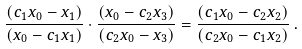Convert formula to latex. <formula><loc_0><loc_0><loc_500><loc_500>\frac { ( c _ { 1 } x _ { 0 } - x _ { 1 } ) } { ( x _ { 0 } - c _ { 1 } x _ { 1 } ) } \cdot \frac { ( x _ { 0 } - c _ { 2 } x _ { 3 } ) } { ( c _ { 2 } x _ { 0 } - x _ { 3 } ) } = \frac { ( c _ { 1 } x _ { 0 } - c _ { 2 } x _ { 2 } ) } { ( c _ { 2 } x _ { 0 } - c _ { 1 } x _ { 2 } ) } \, .</formula> 